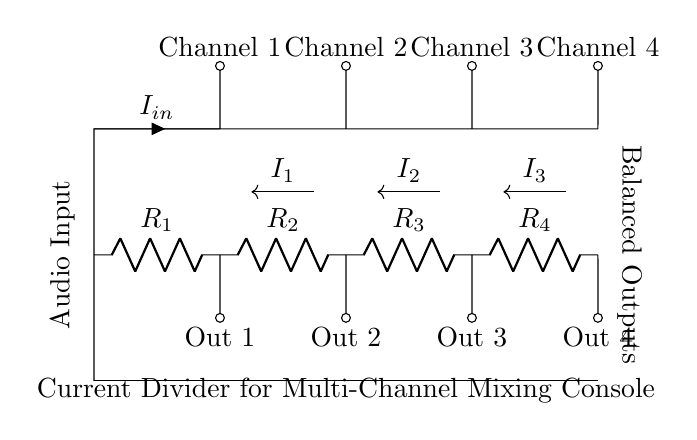What is the input current of the circuit? The input current is denoted as I in the circuit, coming into the node from the left side where the audio input is connected.
Answer: I in What is the resistance of the second resistor? The second resistor is labeled R2 in the circuit diagram, which is specifically indicated next to the component in the sequence.
Answer: R2 What components are connected in parallel? The resistors R1, R2, R3, and R4 are all connected in parallel, as they all connect to the same two voltage nodes and share both ends with their terminals.
Answer: R1, R2, R3, R4 Which output corresponds to Channel 3? The output corresponding to Channel 3 is found at the bottom of the third branch from the left, which is labeled Out 3.
Answer: Out 3 How many channels does this circuit support? The circuit diagram indicates a total of four channels, as shown by the four outputs labeled Out 1, Out 2, Out 3, and Out 4.
Answer: Four What type of circuit is this? This is a current divider circuit, utilized to distribute the input current evenly among the parallel resistors connected to multiple outputs.
Answer: Current divider 